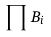<formula> <loc_0><loc_0><loc_500><loc_500>\prod B _ { i }</formula> 